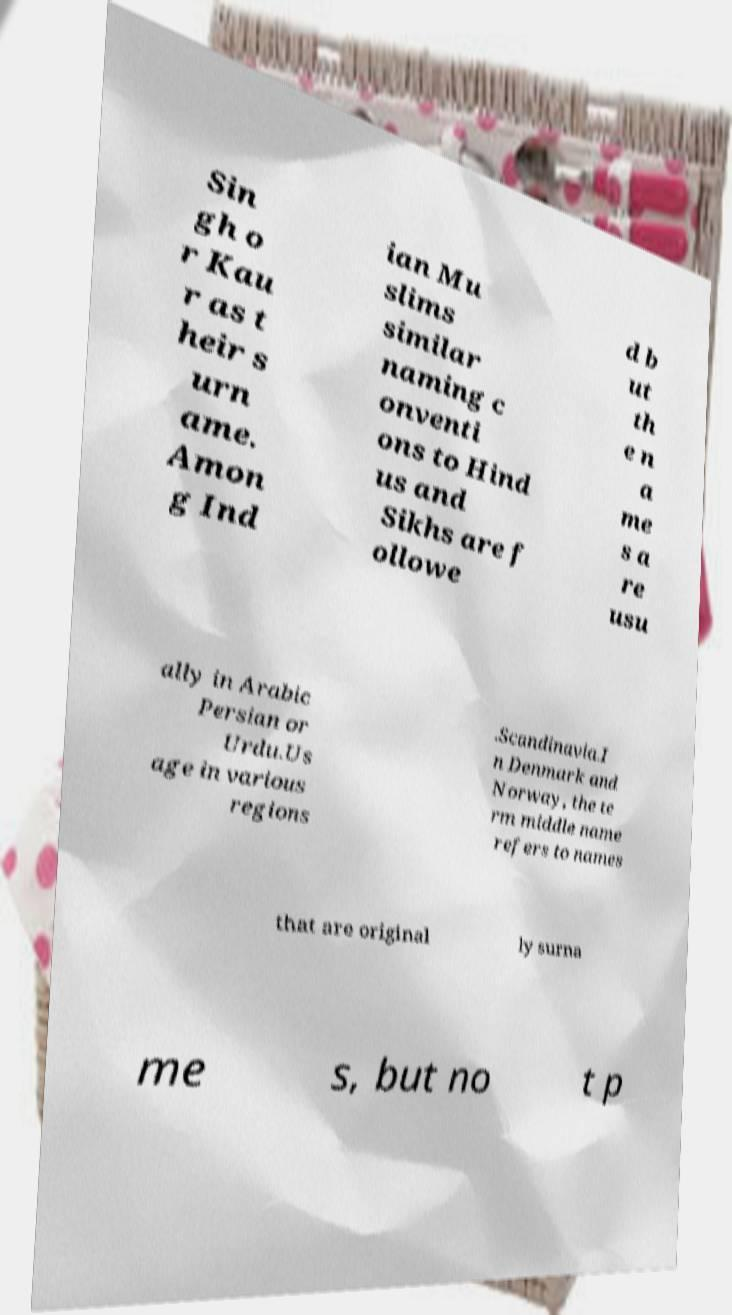For documentation purposes, I need the text within this image transcribed. Could you provide that? Sin gh o r Kau r as t heir s urn ame. Amon g Ind ian Mu slims similar naming c onventi ons to Hind us and Sikhs are f ollowe d b ut th e n a me s a re usu ally in Arabic Persian or Urdu.Us age in various regions .Scandinavia.I n Denmark and Norway, the te rm middle name refers to names that are original ly surna me s, but no t p 